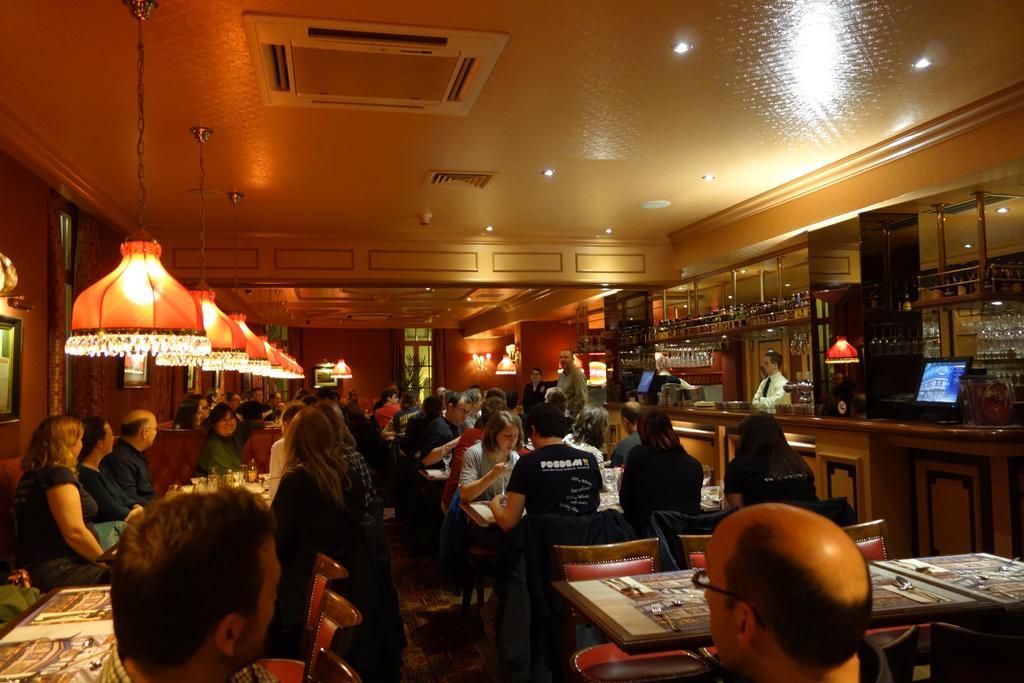How would you summarize this image in a sentence or two? This image is clicked in a restaurant. There are many people sitting in this image. To the right, there is a bar counter. To the left, there is a wall and lights. At the top, there is a roof to which AC and lights are hanged. 